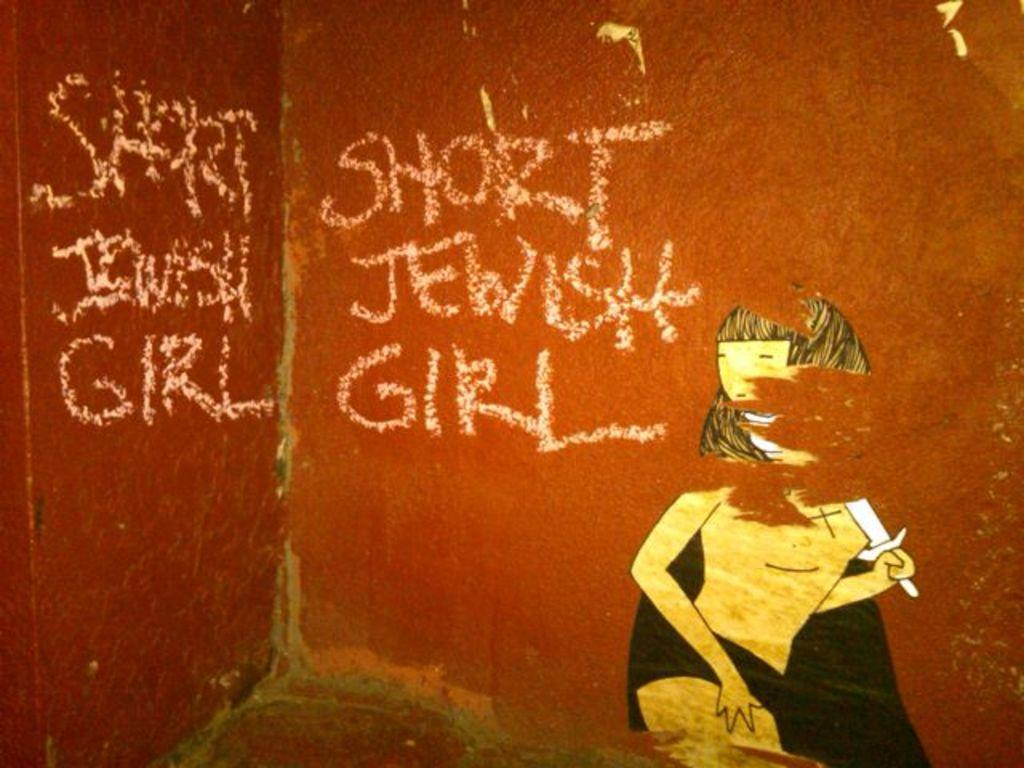How many walls are visible in the image? There are two walls visible in the image. What is written on one of the walls? The text "SHORT JEWISH GIRL" is written on one of the walls in white color paint. What type of hydrant can be seen near the wall with the text? There is no hydrant present in the image. How does the acoustics of the room affect the sound of the text when read aloud? The provided facts do not mention any information about the acoustics of the room, so it cannot be determined how the sound of the text would be affected when read aloud. 